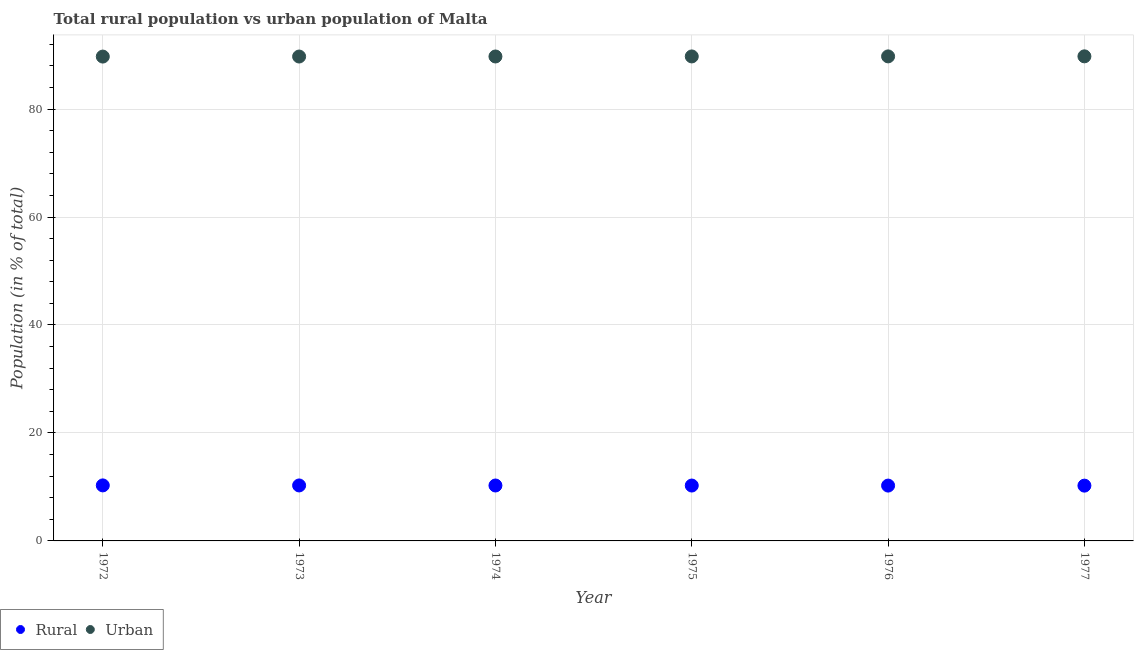What is the urban population in 1977?
Offer a very short reply. 89.76. Across all years, what is the maximum rural population?
Make the answer very short. 10.28. Across all years, what is the minimum urban population?
Keep it short and to the point. 89.72. In which year was the rural population minimum?
Provide a short and direct response. 1977. What is the total urban population in the graph?
Give a very brief answer. 538.43. What is the difference between the rural population in 1975 and that in 1977?
Make the answer very short. 0.02. What is the difference between the urban population in 1975 and the rural population in 1976?
Keep it short and to the point. 79.49. What is the average rural population per year?
Make the answer very short. 10.26. In the year 1972, what is the difference between the rural population and urban population?
Offer a terse response. -79.43. What is the ratio of the rural population in 1974 to that in 1976?
Give a very brief answer. 1. Is the urban population in 1975 less than that in 1976?
Your answer should be very brief. Yes. Is the difference between the rural population in 1973 and 1975 greater than the difference between the urban population in 1973 and 1975?
Give a very brief answer. Yes. What is the difference between the highest and the second highest urban population?
Provide a succinct answer. 0.01. What is the difference between the highest and the lowest urban population?
Provide a short and direct response. 0.04. In how many years, is the rural population greater than the average rural population taken over all years?
Keep it short and to the point. 3. Is the sum of the rural population in 1973 and 1974 greater than the maximum urban population across all years?
Provide a succinct answer. No. Does the rural population monotonically increase over the years?
Your answer should be compact. No. What is the difference between two consecutive major ticks on the Y-axis?
Make the answer very short. 20. Are the values on the major ticks of Y-axis written in scientific E-notation?
Offer a terse response. No. Does the graph contain grids?
Provide a short and direct response. Yes. How many legend labels are there?
Your response must be concise. 2. What is the title of the graph?
Make the answer very short. Total rural population vs urban population of Malta. Does "Female labourers" appear as one of the legend labels in the graph?
Your response must be concise. No. What is the label or title of the X-axis?
Give a very brief answer. Year. What is the label or title of the Y-axis?
Keep it short and to the point. Population (in % of total). What is the Population (in % of total) of Rural in 1972?
Your answer should be compact. 10.28. What is the Population (in % of total) in Urban in 1972?
Keep it short and to the point. 89.72. What is the Population (in % of total) in Rural in 1973?
Your response must be concise. 10.28. What is the Population (in % of total) of Urban in 1973?
Offer a terse response. 89.72. What is the Population (in % of total) in Rural in 1974?
Make the answer very short. 10.27. What is the Population (in % of total) in Urban in 1974?
Offer a terse response. 89.73. What is the Population (in % of total) in Rural in 1975?
Keep it short and to the point. 10.26. What is the Population (in % of total) of Urban in 1975?
Offer a terse response. 89.74. What is the Population (in % of total) in Rural in 1976?
Your answer should be very brief. 10.25. What is the Population (in % of total) of Urban in 1976?
Offer a terse response. 89.75. What is the Population (in % of total) of Rural in 1977?
Your answer should be compact. 10.24. What is the Population (in % of total) in Urban in 1977?
Give a very brief answer. 89.76. Across all years, what is the maximum Population (in % of total) in Rural?
Keep it short and to the point. 10.28. Across all years, what is the maximum Population (in % of total) in Urban?
Provide a succinct answer. 89.76. Across all years, what is the minimum Population (in % of total) of Rural?
Your response must be concise. 10.24. Across all years, what is the minimum Population (in % of total) in Urban?
Your answer should be compact. 89.72. What is the total Population (in % of total) of Rural in the graph?
Provide a short and direct response. 61.57. What is the total Population (in % of total) in Urban in the graph?
Keep it short and to the point. 538.43. What is the difference between the Population (in % of total) in Rural in 1972 and that in 1973?
Give a very brief answer. 0.01. What is the difference between the Population (in % of total) in Urban in 1972 and that in 1973?
Give a very brief answer. -0.01. What is the difference between the Population (in % of total) of Rural in 1972 and that in 1974?
Provide a short and direct response. 0.02. What is the difference between the Population (in % of total) of Urban in 1972 and that in 1974?
Provide a succinct answer. -0.02. What is the difference between the Population (in % of total) in Rural in 1972 and that in 1975?
Keep it short and to the point. 0.03. What is the difference between the Population (in % of total) in Urban in 1972 and that in 1975?
Provide a succinct answer. -0.03. What is the difference between the Population (in % of total) of Rural in 1972 and that in 1976?
Keep it short and to the point. 0.04. What is the difference between the Population (in % of total) of Urban in 1972 and that in 1976?
Ensure brevity in your answer.  -0.04. What is the difference between the Population (in % of total) in Rural in 1972 and that in 1977?
Your answer should be compact. 0.04. What is the difference between the Population (in % of total) of Urban in 1972 and that in 1977?
Offer a terse response. -0.04. What is the difference between the Population (in % of total) of Rural in 1973 and that in 1974?
Your answer should be very brief. 0.01. What is the difference between the Population (in % of total) in Urban in 1973 and that in 1974?
Keep it short and to the point. -0.01. What is the difference between the Population (in % of total) of Rural in 1973 and that in 1975?
Ensure brevity in your answer.  0.02. What is the difference between the Population (in % of total) in Urban in 1973 and that in 1975?
Offer a terse response. -0.02. What is the difference between the Population (in % of total) in Rural in 1973 and that in 1976?
Keep it short and to the point. 0.03. What is the difference between the Population (in % of total) of Urban in 1973 and that in 1976?
Your answer should be compact. -0.03. What is the difference between the Population (in % of total) of Rural in 1973 and that in 1977?
Provide a succinct answer. 0.04. What is the difference between the Population (in % of total) in Urban in 1973 and that in 1977?
Give a very brief answer. -0.04. What is the difference between the Population (in % of total) in Rural in 1974 and that in 1975?
Your answer should be very brief. 0.01. What is the difference between the Population (in % of total) in Urban in 1974 and that in 1975?
Your answer should be compact. -0.01. What is the difference between the Population (in % of total) of Rural in 1974 and that in 1976?
Keep it short and to the point. 0.02. What is the difference between the Population (in % of total) in Urban in 1974 and that in 1976?
Offer a terse response. -0.02. What is the difference between the Population (in % of total) of Rural in 1974 and that in 1977?
Offer a very short reply. 0.03. What is the difference between the Population (in % of total) of Urban in 1974 and that in 1977?
Provide a succinct answer. -0.03. What is the difference between the Population (in % of total) in Rural in 1975 and that in 1976?
Your response must be concise. 0.01. What is the difference between the Population (in % of total) of Urban in 1975 and that in 1976?
Make the answer very short. -0.01. What is the difference between the Population (in % of total) in Rural in 1975 and that in 1977?
Offer a very short reply. 0.02. What is the difference between the Population (in % of total) of Urban in 1975 and that in 1977?
Keep it short and to the point. -0.02. What is the difference between the Population (in % of total) of Rural in 1976 and that in 1977?
Keep it short and to the point. 0.01. What is the difference between the Population (in % of total) of Urban in 1976 and that in 1977?
Provide a short and direct response. -0.01. What is the difference between the Population (in % of total) of Rural in 1972 and the Population (in % of total) of Urban in 1973?
Provide a short and direct response. -79.44. What is the difference between the Population (in % of total) of Rural in 1972 and the Population (in % of total) of Urban in 1974?
Offer a terse response. -79.45. What is the difference between the Population (in % of total) of Rural in 1972 and the Population (in % of total) of Urban in 1975?
Provide a succinct answer. -79.46. What is the difference between the Population (in % of total) of Rural in 1972 and the Population (in % of total) of Urban in 1976?
Provide a succinct answer. -79.47. What is the difference between the Population (in % of total) of Rural in 1972 and the Population (in % of total) of Urban in 1977?
Provide a succinct answer. -79.48. What is the difference between the Population (in % of total) in Rural in 1973 and the Population (in % of total) in Urban in 1974?
Keep it short and to the point. -79.46. What is the difference between the Population (in % of total) of Rural in 1973 and the Population (in % of total) of Urban in 1975?
Ensure brevity in your answer.  -79.47. What is the difference between the Population (in % of total) of Rural in 1973 and the Population (in % of total) of Urban in 1976?
Your answer should be compact. -79.48. What is the difference between the Population (in % of total) in Rural in 1973 and the Population (in % of total) in Urban in 1977?
Ensure brevity in your answer.  -79.48. What is the difference between the Population (in % of total) in Rural in 1974 and the Population (in % of total) in Urban in 1975?
Make the answer very short. -79.48. What is the difference between the Population (in % of total) in Rural in 1974 and the Population (in % of total) in Urban in 1976?
Give a very brief answer. -79.48. What is the difference between the Population (in % of total) of Rural in 1974 and the Population (in % of total) of Urban in 1977?
Provide a short and direct response. -79.49. What is the difference between the Population (in % of total) of Rural in 1975 and the Population (in % of total) of Urban in 1976?
Provide a succinct answer. -79.49. What is the difference between the Population (in % of total) in Rural in 1975 and the Population (in % of total) in Urban in 1977?
Offer a terse response. -79.5. What is the difference between the Population (in % of total) of Rural in 1976 and the Population (in % of total) of Urban in 1977?
Your answer should be very brief. -79.51. What is the average Population (in % of total) in Rural per year?
Offer a very short reply. 10.26. What is the average Population (in % of total) in Urban per year?
Offer a very short reply. 89.74. In the year 1972, what is the difference between the Population (in % of total) of Rural and Population (in % of total) of Urban?
Offer a very short reply. -79.43. In the year 1973, what is the difference between the Population (in % of total) in Rural and Population (in % of total) in Urban?
Make the answer very short. -79.45. In the year 1974, what is the difference between the Population (in % of total) in Rural and Population (in % of total) in Urban?
Offer a terse response. -79.47. In the year 1975, what is the difference between the Population (in % of total) in Rural and Population (in % of total) in Urban?
Provide a short and direct response. -79.48. In the year 1976, what is the difference between the Population (in % of total) of Rural and Population (in % of total) of Urban?
Provide a succinct answer. -79.5. In the year 1977, what is the difference between the Population (in % of total) in Rural and Population (in % of total) in Urban?
Offer a very short reply. -79.52. What is the ratio of the Population (in % of total) of Rural in 1972 to that in 1973?
Give a very brief answer. 1. What is the ratio of the Population (in % of total) of Urban in 1972 to that in 1973?
Offer a very short reply. 1. What is the ratio of the Population (in % of total) of Rural in 1972 to that in 1974?
Offer a very short reply. 1. What is the ratio of the Population (in % of total) of Urban in 1972 to that in 1974?
Your answer should be very brief. 1. What is the ratio of the Population (in % of total) in Rural in 1972 to that in 1977?
Keep it short and to the point. 1. What is the ratio of the Population (in % of total) of Urban in 1972 to that in 1977?
Keep it short and to the point. 1. What is the ratio of the Population (in % of total) of Rural in 1973 to that in 1975?
Provide a short and direct response. 1. What is the ratio of the Population (in % of total) of Rural in 1973 to that in 1976?
Provide a succinct answer. 1. What is the ratio of the Population (in % of total) in Rural in 1973 to that in 1977?
Your answer should be compact. 1. What is the ratio of the Population (in % of total) in Rural in 1974 to that in 1976?
Ensure brevity in your answer.  1. What is the ratio of the Population (in % of total) in Rural in 1974 to that in 1977?
Give a very brief answer. 1. What is the ratio of the Population (in % of total) in Urban in 1974 to that in 1977?
Make the answer very short. 1. What is the ratio of the Population (in % of total) of Urban in 1975 to that in 1977?
Offer a very short reply. 1. What is the ratio of the Population (in % of total) of Urban in 1976 to that in 1977?
Your answer should be very brief. 1. What is the difference between the highest and the second highest Population (in % of total) of Rural?
Make the answer very short. 0.01. What is the difference between the highest and the second highest Population (in % of total) in Urban?
Ensure brevity in your answer.  0.01. What is the difference between the highest and the lowest Population (in % of total) in Rural?
Give a very brief answer. 0.04. What is the difference between the highest and the lowest Population (in % of total) of Urban?
Your answer should be compact. 0.04. 